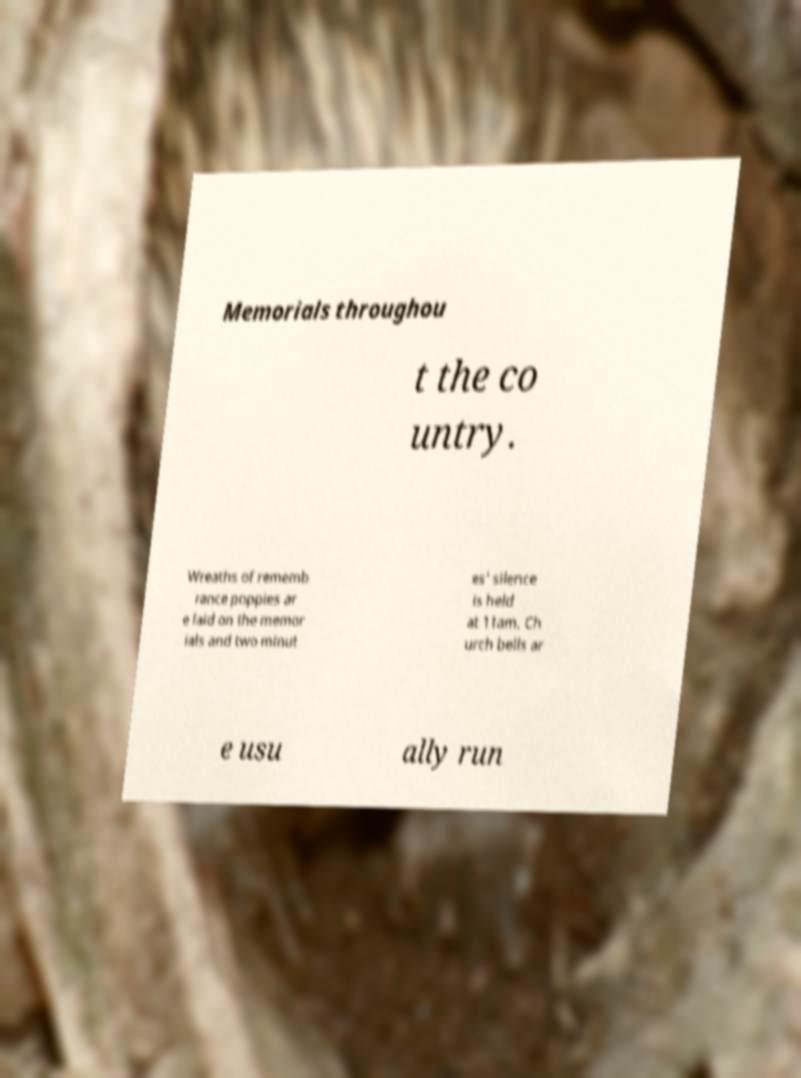For documentation purposes, I need the text within this image transcribed. Could you provide that? Memorials throughou t the co untry. Wreaths of rememb rance poppies ar e laid on the memor ials and two minut es' silence is held at 11am. Ch urch bells ar e usu ally run 